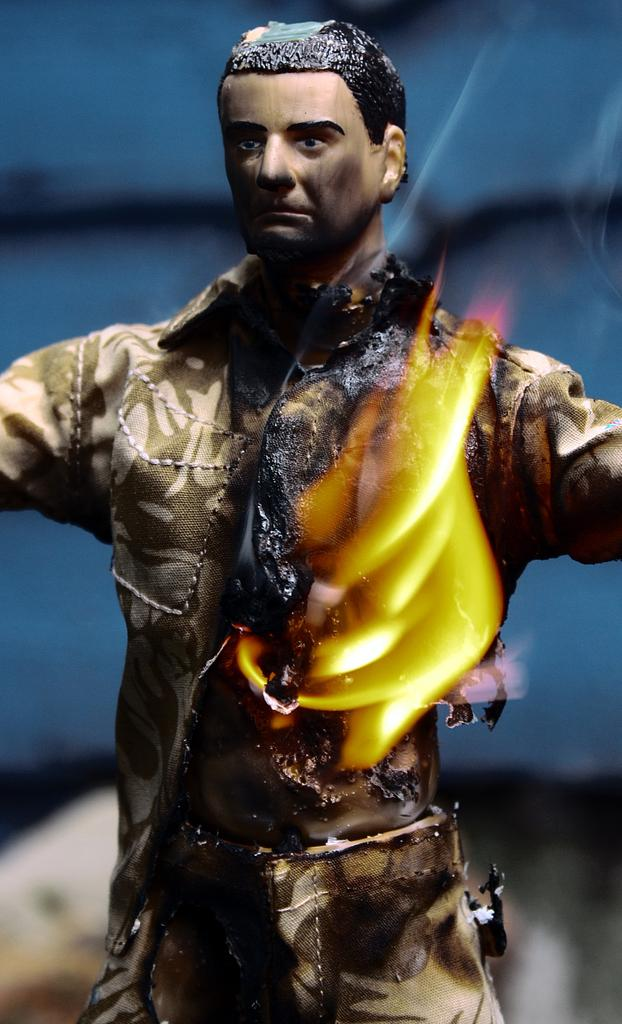What type of object is depicted in the image? There is a toy of a person wearing clothes in the image. What event is taking place in the image? There is a fire in the image. Can you describe the background of the image? The background of the image is blurred. How many plants are visible in the image? There are no plants visible in the image. 